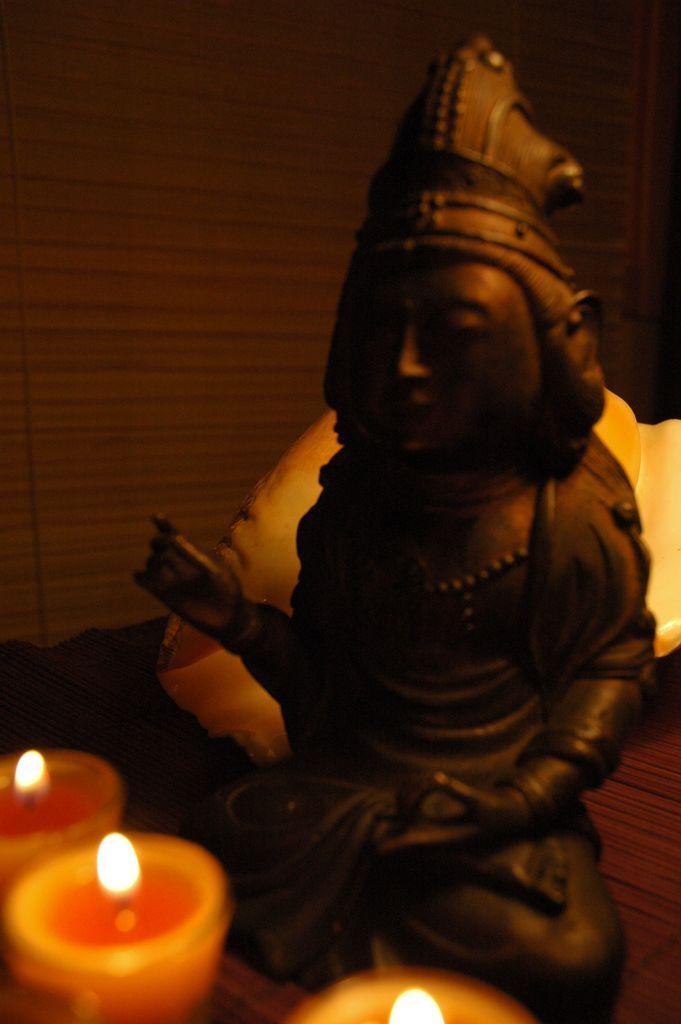Describe this image in one or two sentences. In this image I can see a god statue. In front I can see three candles. Background is in brown and black color. 